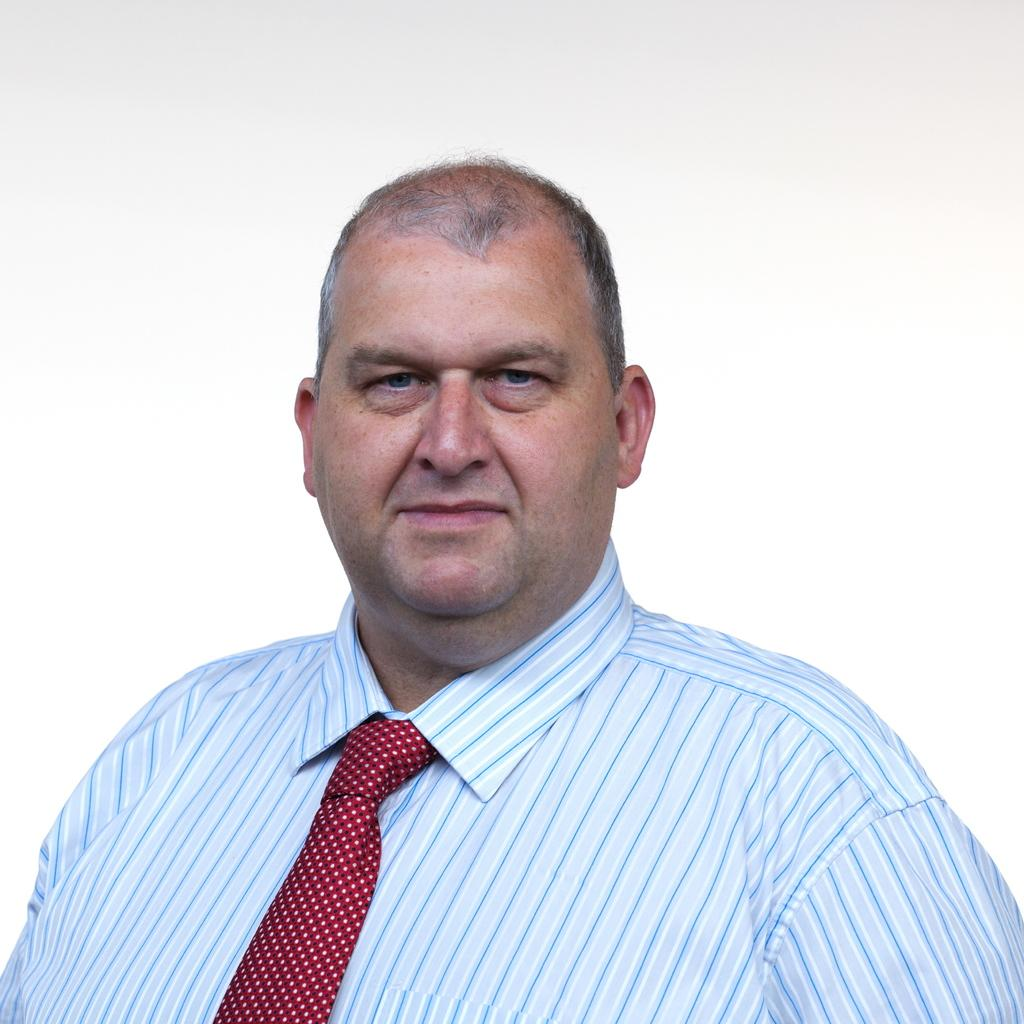What is the main subject of the image? There is a person standing in the middle of the image. What is the person doing in the image? The person is smiling. What can be seen behind the person in the image? There is a wall visible behind the person. What type of worm can be seen crawling on the person's shoulder in the image? There is no worm present on the person's shoulder in the image. What kind of soap is the person holding in the image? There is no soap visible in the image; the person is simply standing and smiling. 